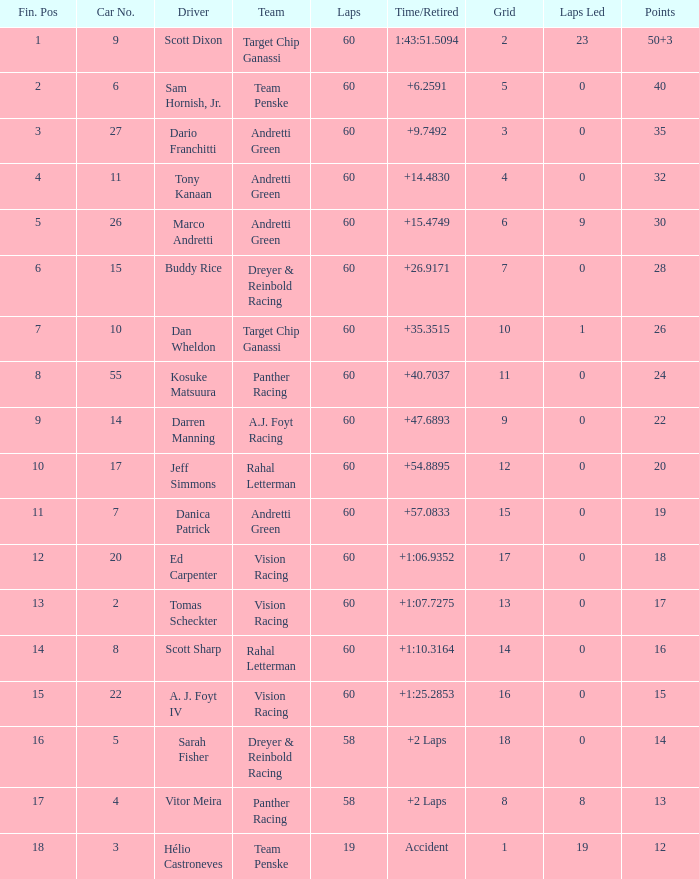Can you give me this table as a dict? {'header': ['Fin. Pos', 'Car No.', 'Driver', 'Team', 'Laps', 'Time/Retired', 'Grid', 'Laps Led', 'Points'], 'rows': [['1', '9', 'Scott Dixon', 'Target Chip Ganassi', '60', '1:43:51.5094', '2', '23', '50+3'], ['2', '6', 'Sam Hornish, Jr.', 'Team Penske', '60', '+6.2591', '5', '0', '40'], ['3', '27', 'Dario Franchitti', 'Andretti Green', '60', '+9.7492', '3', '0', '35'], ['4', '11', 'Tony Kanaan', 'Andretti Green', '60', '+14.4830', '4', '0', '32'], ['5', '26', 'Marco Andretti', 'Andretti Green', '60', '+15.4749', '6', '9', '30'], ['6', '15', 'Buddy Rice', 'Dreyer & Reinbold Racing', '60', '+26.9171', '7', '0', '28'], ['7', '10', 'Dan Wheldon', 'Target Chip Ganassi', '60', '+35.3515', '10', '1', '26'], ['8', '55', 'Kosuke Matsuura', 'Panther Racing', '60', '+40.7037', '11', '0', '24'], ['9', '14', 'Darren Manning', 'A.J. Foyt Racing', '60', '+47.6893', '9', '0', '22'], ['10', '17', 'Jeff Simmons', 'Rahal Letterman', '60', '+54.8895', '12', '0', '20'], ['11', '7', 'Danica Patrick', 'Andretti Green', '60', '+57.0833', '15', '0', '19'], ['12', '20', 'Ed Carpenter', 'Vision Racing', '60', '+1:06.9352', '17', '0', '18'], ['13', '2', 'Tomas Scheckter', 'Vision Racing', '60', '+1:07.7275', '13', '0', '17'], ['14', '8', 'Scott Sharp', 'Rahal Letterman', '60', '+1:10.3164', '14', '0', '16'], ['15', '22', 'A. J. Foyt IV', 'Vision Racing', '60', '+1:25.2853', '16', '0', '15'], ['16', '5', 'Sarah Fisher', 'Dreyer & Reinbold Racing', '58', '+2 Laps', '18', '0', '14'], ['17', '4', 'Vitor Meira', 'Panther Racing', '58', '+2 Laps', '8', '8', '13'], ['18', '3', 'Hélio Castroneves', 'Team Penske', '19', 'Accident', '1', '19', '12']]} Name the drive for points being 13 Vitor Meira. 